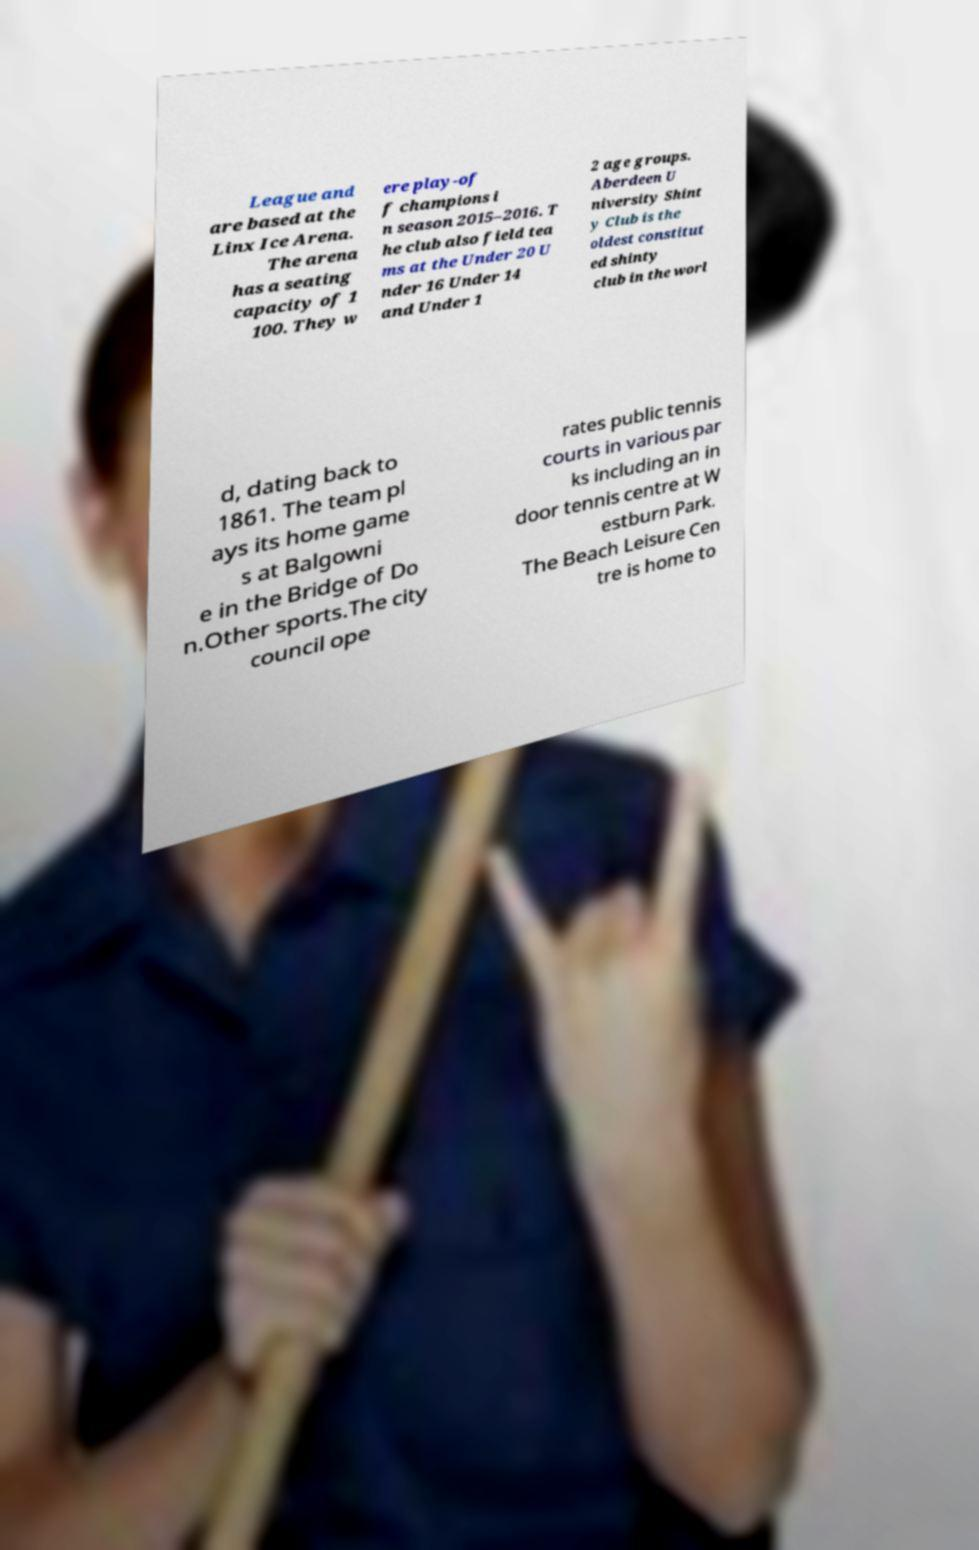Can you read and provide the text displayed in the image?This photo seems to have some interesting text. Can you extract and type it out for me? League and are based at the Linx Ice Arena. The arena has a seating capacity of 1 100. They w ere play-of f champions i n season 2015–2016. T he club also field tea ms at the Under 20 U nder 16 Under 14 and Under 1 2 age groups. Aberdeen U niversity Shint y Club is the oldest constitut ed shinty club in the worl d, dating back to 1861. The team pl ays its home game s at Balgowni e in the Bridge of Do n.Other sports.The city council ope rates public tennis courts in various par ks including an in door tennis centre at W estburn Park. The Beach Leisure Cen tre is home to 